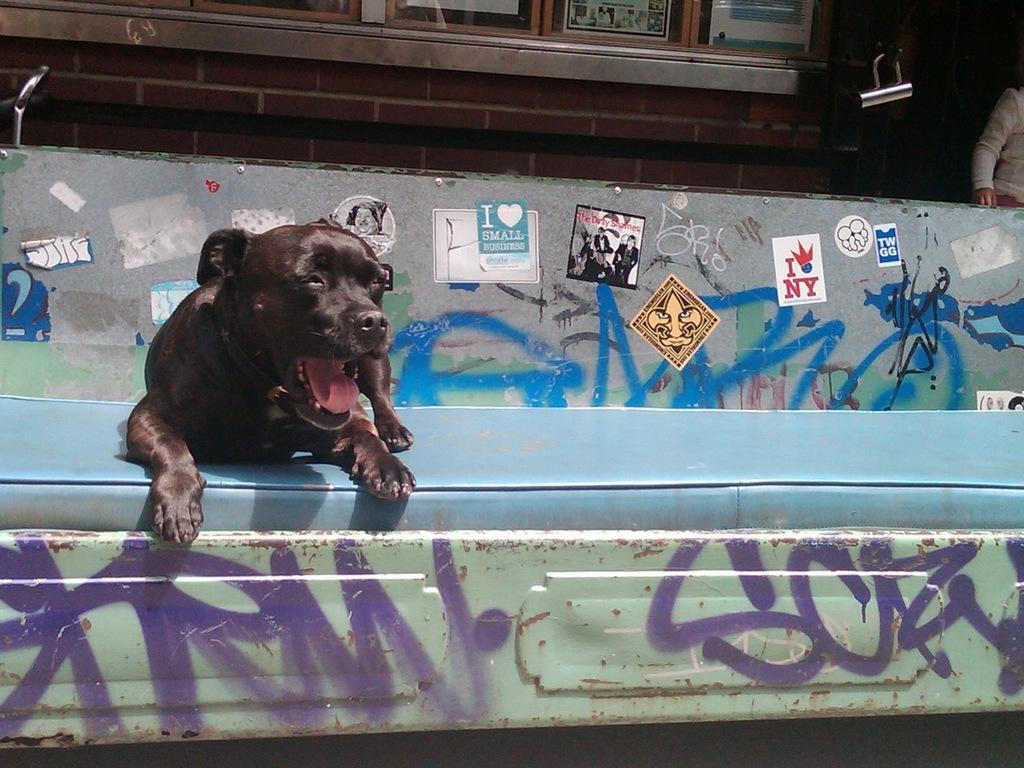Please provide a concise description of this image. In this image I can see the blue colored object and on it I can see a dog which is brown and black in color. I can see few posts attached to the wall, a person and a building in the background. 